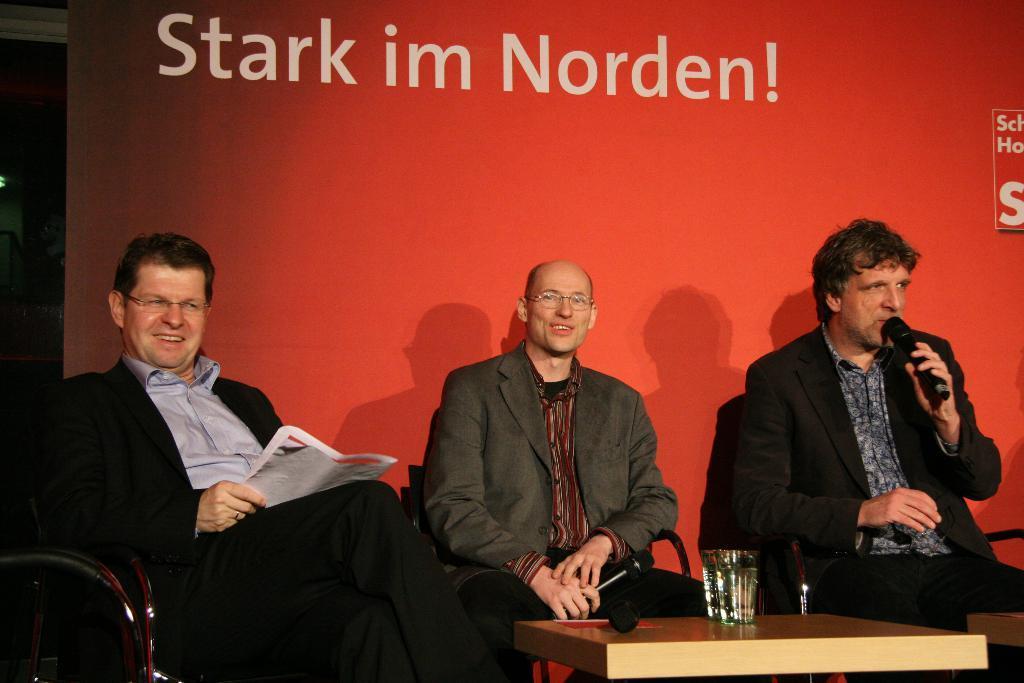In one or two sentences, can you explain what this image depicts? The person in the right is sitting and speaking in front of a mic and there are two other persons sitting beside him and there is a table beside him which has a glass of water in it. The background is red in color with something written on it. 